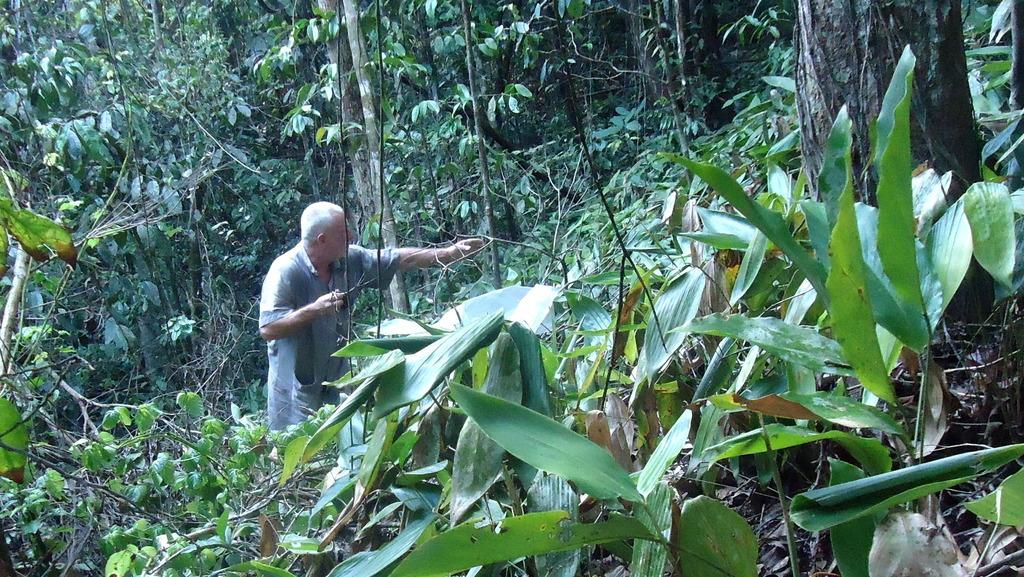Who is present in the image? There is a man in the image. What type of natural elements can be seen in the image? There are trees and plants in the image. What type of metal can be seen in the image? There is no metal present in the image; it features a man, trees, and plants. Where is the store located in the image? There is no store present in the image. 